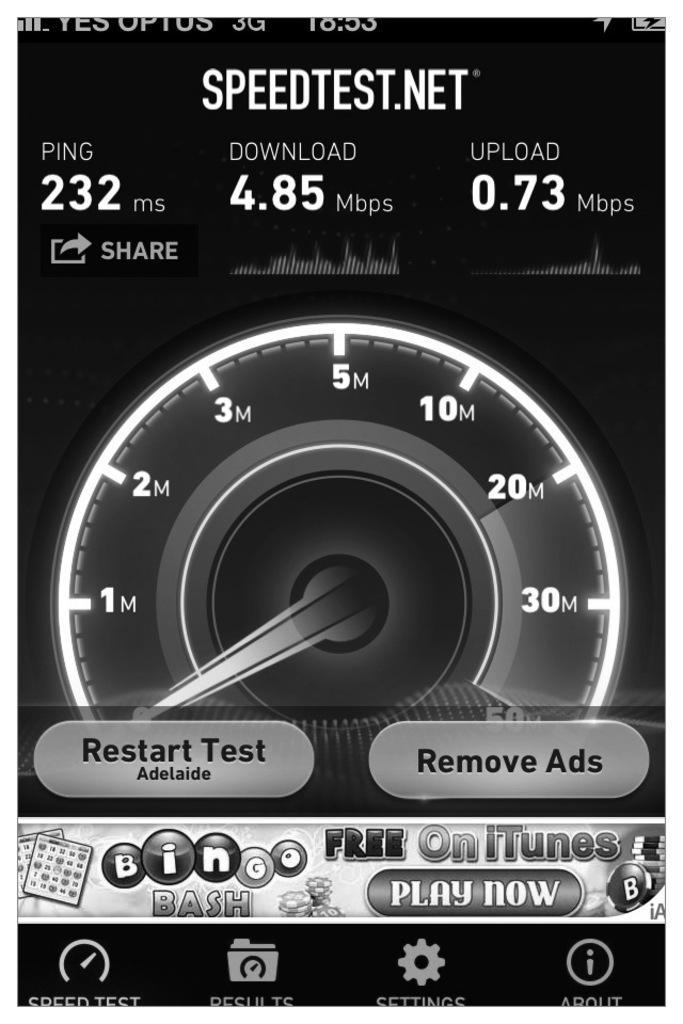In one or two sentences, can you explain what this image depicts? This is an animation in this image in the center there is a speed meter and on the top and at the bottom of the image there is some text. 